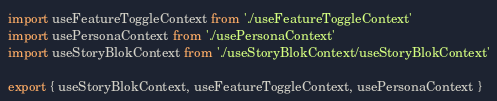<code> <loc_0><loc_0><loc_500><loc_500><_TypeScript_>import useFeatureToggleContext from './useFeatureToggleContext'
import usePersonaContext from './usePersonaContext'
import useStoryBlokContext from './useStoryBlokContext/useStoryBlokContext'

export { useStoryBlokContext, useFeatureToggleContext, usePersonaContext }
</code> 